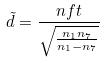Convert formula to latex. <formula><loc_0><loc_0><loc_500><loc_500>\tilde { d } = \frac { n f t } { \sqrt { \frac { n _ { 1 } n _ { 7 } } { n _ { 1 } - n _ { 7 } } } }</formula> 